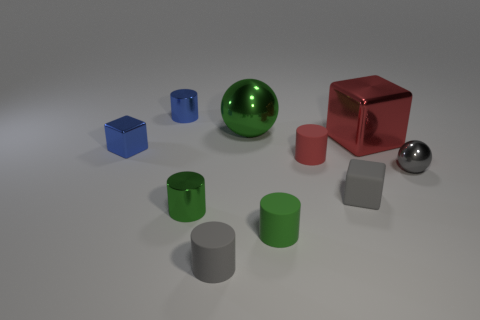What color is the large metal block?
Your response must be concise. Red. How many objects are small green cylinders or tiny brown rubber spheres?
Offer a terse response. 2. There is a blue cylinder that is the same size as the gray matte block; what is its material?
Offer a terse response. Metal. There is a ball that is right of the red block; what size is it?
Provide a succinct answer. Small. What is the material of the gray ball?
Make the answer very short. Metal. How many objects are metal spheres that are behind the tiny metallic sphere or large metallic objects on the left side of the matte cube?
Your answer should be very brief. 1. What number of other objects are the same color as the small matte cube?
Your answer should be very brief. 2. Is the shape of the gray shiny object the same as the tiny matte thing behind the small sphere?
Offer a very short reply. No. Are there fewer small blue metallic objects that are in front of the small blue shiny cylinder than blue cylinders behind the gray shiny ball?
Your answer should be compact. No. What material is the other big object that is the same shape as the gray shiny thing?
Offer a terse response. Metal. 